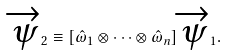Convert formula to latex. <formula><loc_0><loc_0><loc_500><loc_500>\overrightarrow { \psi } _ { 2 } \equiv [ \hat { \omega } _ { 1 } \otimes \cdots \otimes \hat { \omega } _ { n } ] \overrightarrow { \psi } _ { 1 } .</formula> 